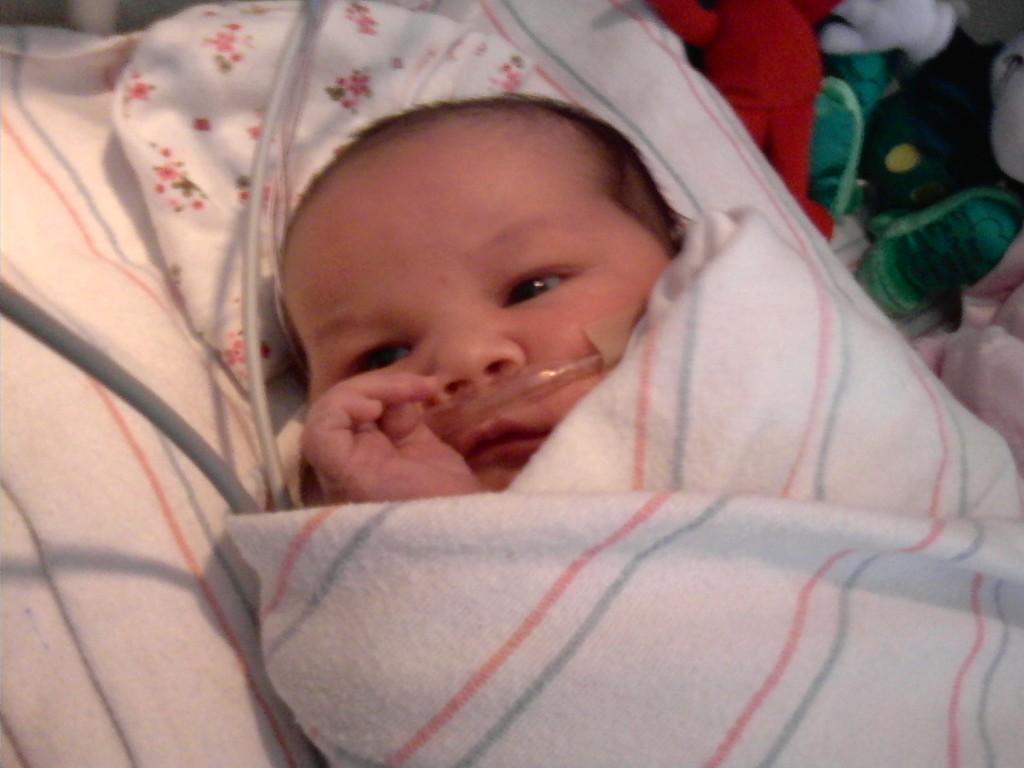Please provide a concise description of this image. In this image I can see the baby is wrapped in the cloth. I can see few wires and few objects around. 